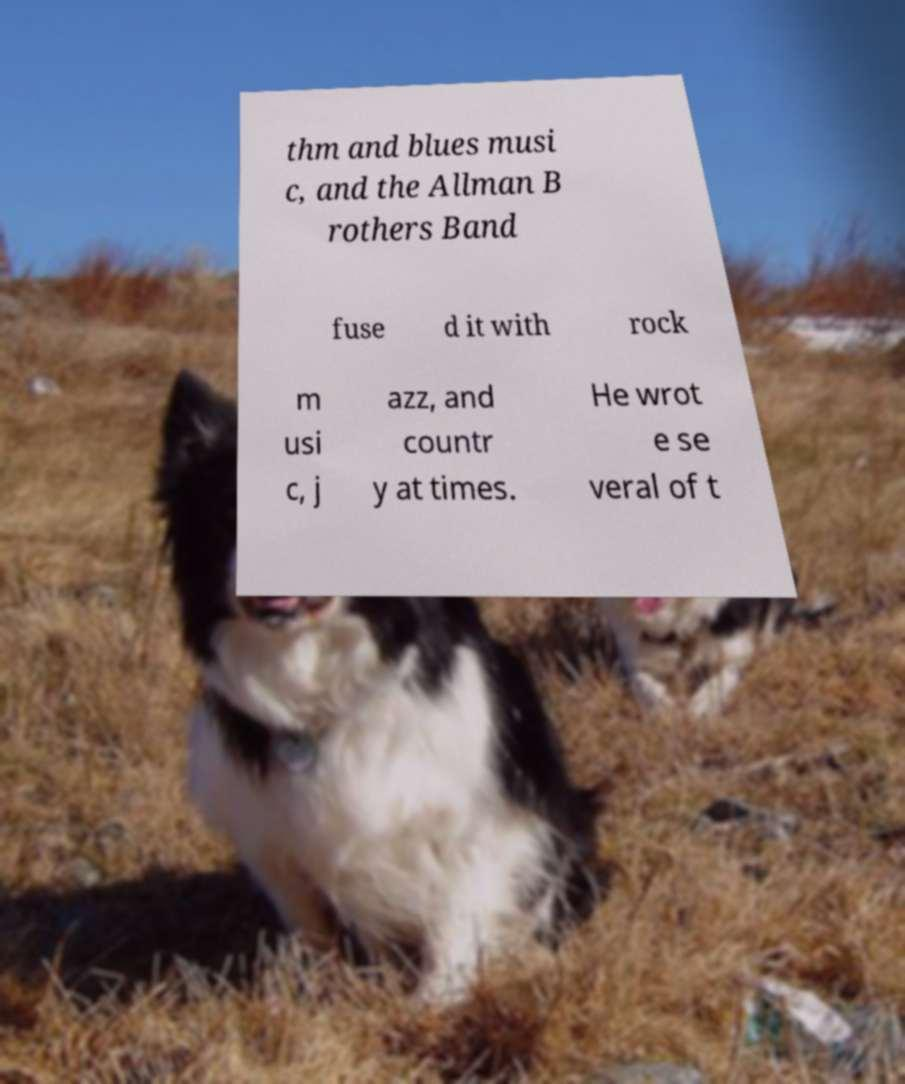Could you extract and type out the text from this image? thm and blues musi c, and the Allman B rothers Band fuse d it with rock m usi c, j azz, and countr y at times. He wrot e se veral of t 